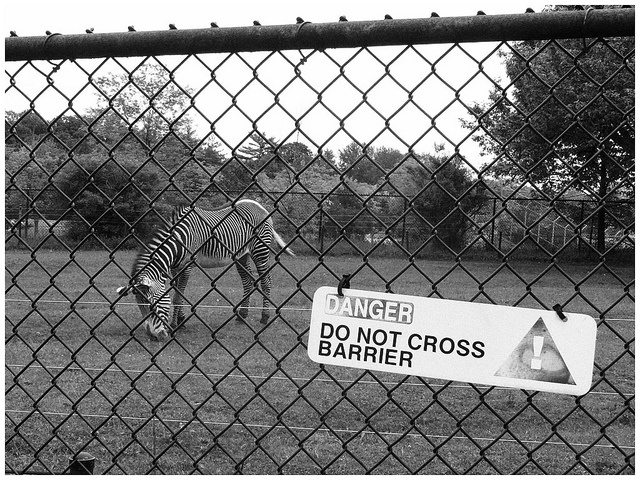Describe the objects in this image and their specific colors. I can see a zebra in white, black, gray, darkgray, and lightgray tones in this image. 